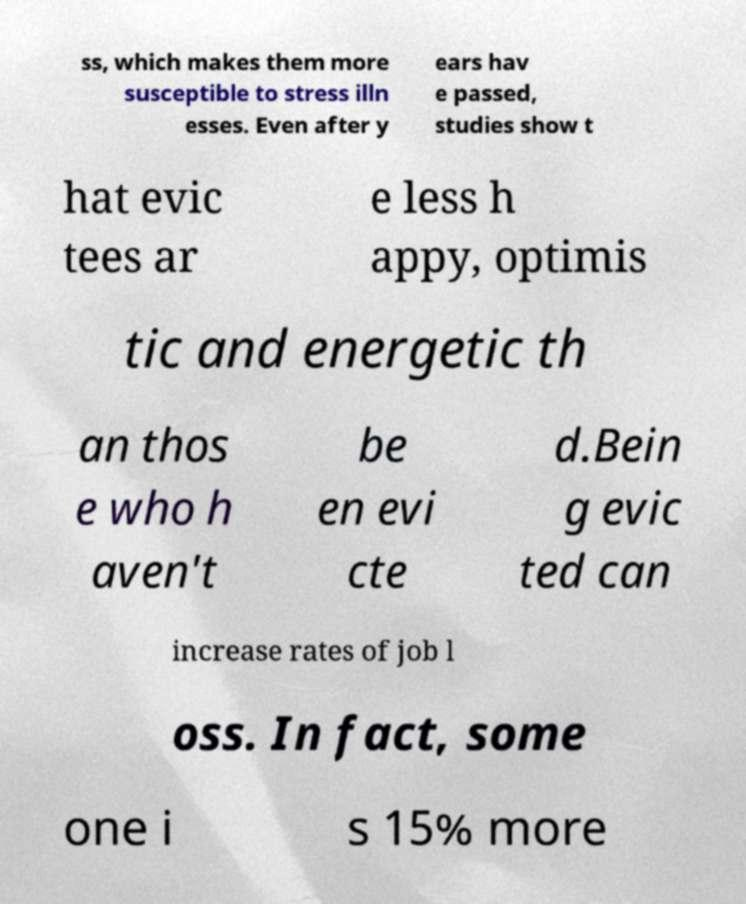For documentation purposes, I need the text within this image transcribed. Could you provide that? ss, which makes them more susceptible to stress illn esses. Even after y ears hav e passed, studies show t hat evic tees ar e less h appy, optimis tic and energetic th an thos e who h aven't be en evi cte d.Bein g evic ted can increase rates of job l oss. In fact, some one i s 15% more 